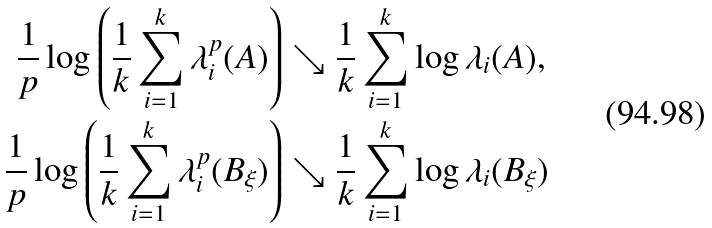Convert formula to latex. <formula><loc_0><loc_0><loc_500><loc_500>{ \frac { 1 } { p } } \log \left ( { \frac { 1 } { k } } \sum _ { i = 1 } ^ { k } \lambda _ { i } ^ { p } ( A ) \right ) & \searrow { \frac { 1 } { k } } \sum _ { i = 1 } ^ { k } \log \lambda _ { i } ( A ) , \\ { \frac { 1 } { p } } \log \left ( { \frac { 1 } { k } } \sum _ { i = 1 } ^ { k } \lambda _ { i } ^ { p } ( B _ { \xi } ) \right ) & \searrow { \frac { 1 } { k } } \sum _ { i = 1 } ^ { k } \log \lambda _ { i } ( B _ { \xi } )</formula> 